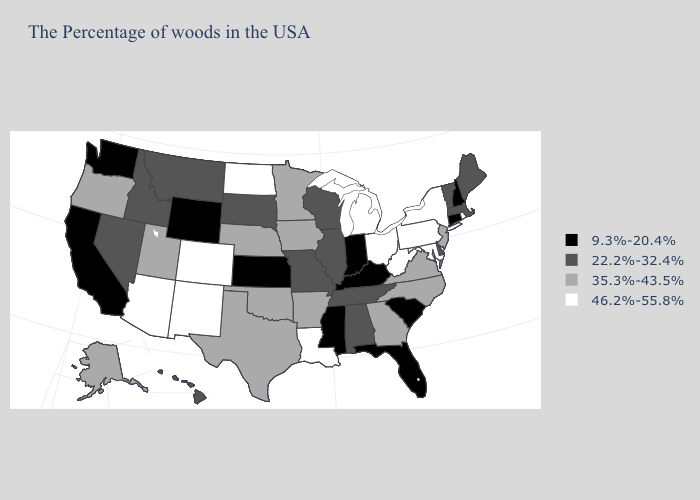Which states hav the highest value in the West?
Concise answer only. Colorado, New Mexico, Arizona. Does the first symbol in the legend represent the smallest category?
Answer briefly. Yes. What is the value of Georgia?
Short answer required. 35.3%-43.5%. Does Ohio have the highest value in the MidWest?
Give a very brief answer. Yes. What is the value of Oregon?
Give a very brief answer. 35.3%-43.5%. Does Kansas have the lowest value in the USA?
Give a very brief answer. Yes. Which states have the highest value in the USA?
Short answer required. Rhode Island, New York, Maryland, Pennsylvania, West Virginia, Ohio, Michigan, Louisiana, North Dakota, Colorado, New Mexico, Arizona. Among the states that border Virginia , which have the highest value?
Short answer required. Maryland, West Virginia. Among the states that border Missouri , does Oklahoma have the lowest value?
Write a very short answer. No. What is the value of South Carolina?
Short answer required. 9.3%-20.4%. Which states hav the highest value in the MidWest?
Answer briefly. Ohio, Michigan, North Dakota. Name the states that have a value in the range 35.3%-43.5%?
Be succinct. New Jersey, Virginia, North Carolina, Georgia, Arkansas, Minnesota, Iowa, Nebraska, Oklahoma, Texas, Utah, Oregon, Alaska. What is the value of North Dakota?
Keep it brief. 46.2%-55.8%. What is the value of Idaho?
Short answer required. 22.2%-32.4%. 